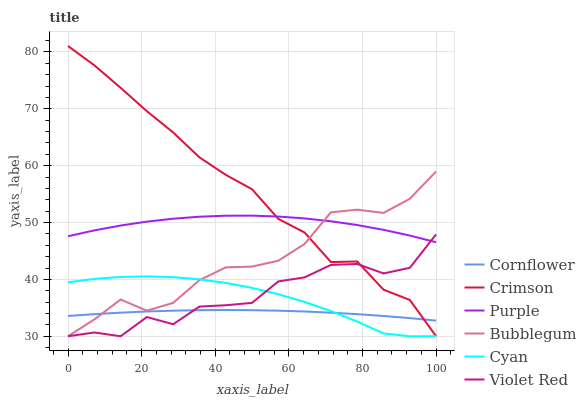Does Cornflower have the minimum area under the curve?
Answer yes or no. Yes. Does Crimson have the maximum area under the curve?
Answer yes or no. Yes. Does Violet Red have the minimum area under the curve?
Answer yes or no. No. Does Violet Red have the maximum area under the curve?
Answer yes or no. No. Is Cornflower the smoothest?
Answer yes or no. Yes. Is Violet Red the roughest?
Answer yes or no. Yes. Is Purple the smoothest?
Answer yes or no. No. Is Purple the roughest?
Answer yes or no. No. Does Purple have the lowest value?
Answer yes or no. No. Does Crimson have the highest value?
Answer yes or no. Yes. Does Violet Red have the highest value?
Answer yes or no. No. Is Cornflower less than Purple?
Answer yes or no. Yes. Is Purple greater than Cyan?
Answer yes or no. Yes. Does Violet Red intersect Cornflower?
Answer yes or no. Yes. Is Violet Red less than Cornflower?
Answer yes or no. No. Is Violet Red greater than Cornflower?
Answer yes or no. No. Does Cornflower intersect Purple?
Answer yes or no. No. 